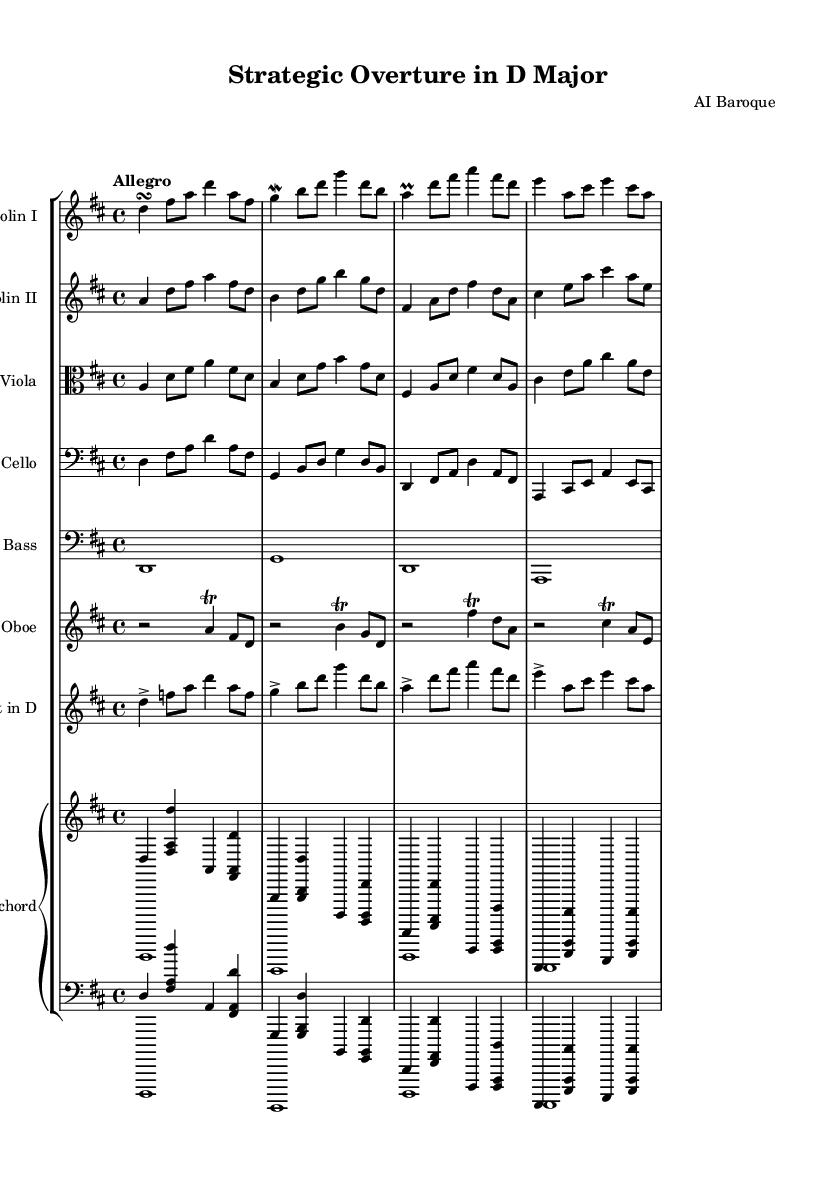What is the key signature of this music? The key signature shows two sharps (F# and C#) on the staff, indicating that the composition is in D major.
Answer: D major What is the time signature of this piece? The time signature is indicated at the beginning of the sheet music and is shown as 4/4, meaning there are four beats per measure.
Answer: 4/4 What is the tempo marking for this piece? The tempo marking written above the staff indicates "Allegro," which signifies a fast pace.
Answer: Allegro How many instruments are indicated in the orchestral suite? By counting each staff line for the instruments, there are a total of eight instruments represented in the score.
Answer: Eight Which instruments are featured in this orchestral suite? The instruments listed on the score include Violin I, Violin II, Viola, Cello, Double Bass, Oboe, Trumpet in D, and Harpsichord, totaling eight.
Answer: Violin I, Violin II, Viola, Cello, Double Bass, Oboe, Trumpet in D, Harpsichord What is the primary role of the harpsichord in this piece? The harpsichord typically provides the harmonic foundation and is often seen as a continuo instrument in Baroque music, supporting the other parts.
Answer: Continuo What ornament is used in the oboe part? The oboe part features trills, indicated by the symbols placed above the notes, demonstrating a common Baroque embellishment technique.
Answer: Trills 